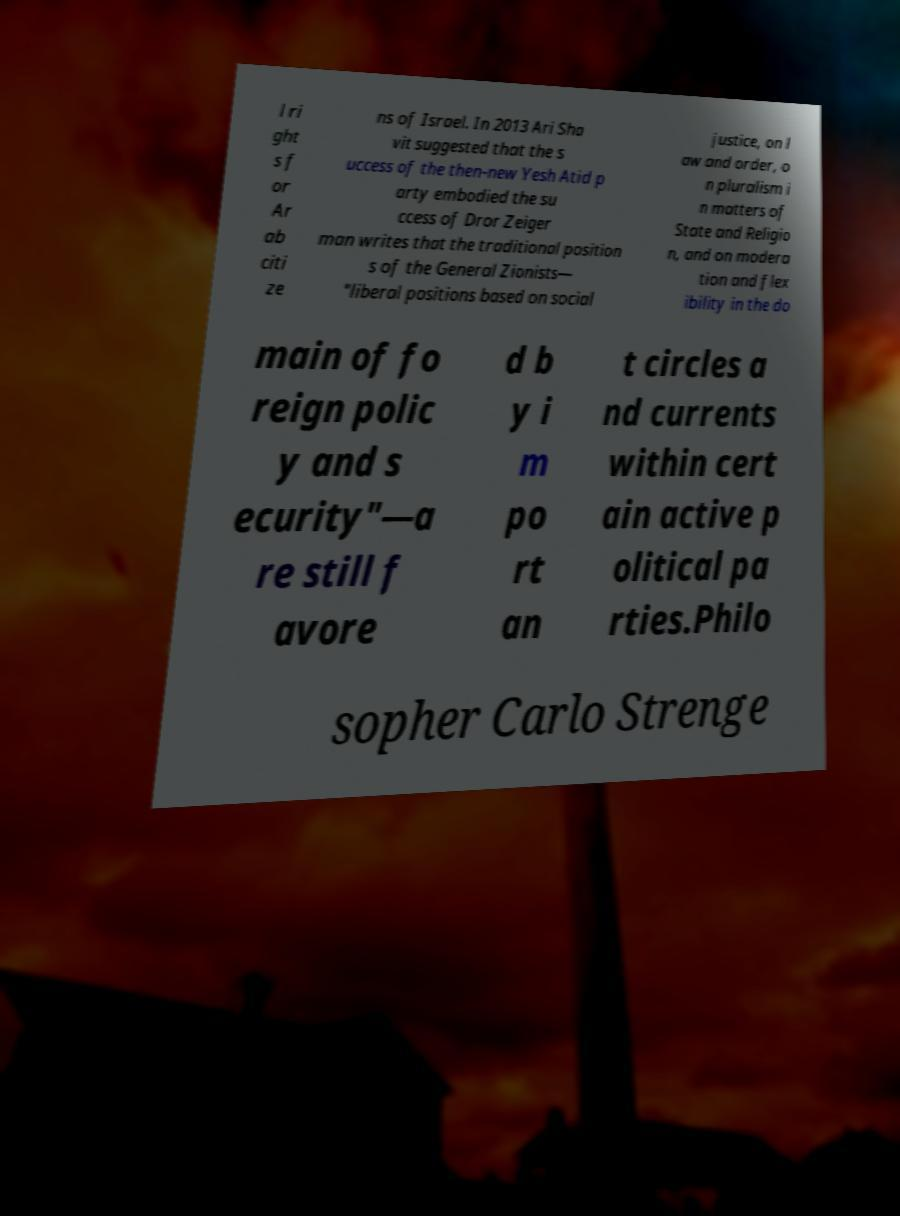Can you read and provide the text displayed in the image?This photo seems to have some interesting text. Can you extract and type it out for me? l ri ght s f or Ar ab citi ze ns of Israel. In 2013 Ari Sha vit suggested that the s uccess of the then-new Yesh Atid p arty embodied the su ccess of Dror Zeiger man writes that the traditional position s of the General Zionists— "liberal positions based on social justice, on l aw and order, o n pluralism i n matters of State and Religio n, and on modera tion and flex ibility in the do main of fo reign polic y and s ecurity"—a re still f avore d b y i m po rt an t circles a nd currents within cert ain active p olitical pa rties.Philo sopher Carlo Strenge 